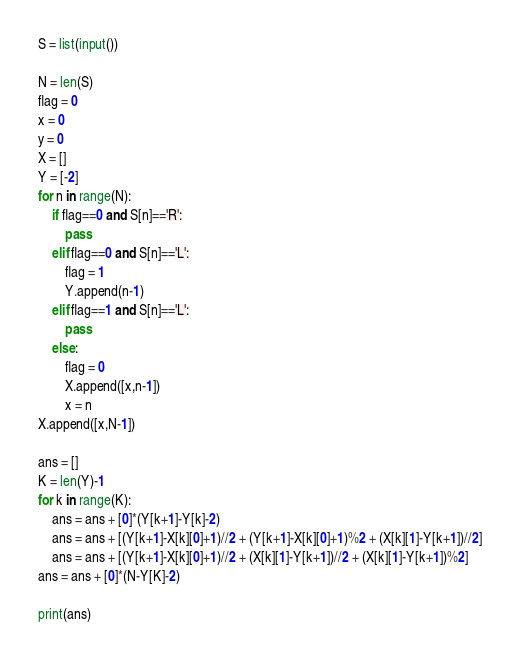<code> <loc_0><loc_0><loc_500><loc_500><_Python_>S = list(input())

N = len(S)
flag = 0
x = 0
y = 0
X = []
Y = [-2]
for n in range(N):
    if flag==0 and S[n]=='R':
        pass
    elif flag==0 and S[n]=='L':
        flag = 1
        Y.append(n-1)
    elif flag==1 and S[n]=='L':
        pass
    else:
        flag = 0
        X.append([x,n-1])
        x = n
X.append([x,N-1])

ans = []
K = len(Y)-1
for k in range(K):
    ans = ans + [0]*(Y[k+1]-Y[k]-2)
    ans = ans + [(Y[k+1]-X[k][0]+1)//2 + (Y[k+1]-X[k][0]+1)%2 + (X[k][1]-Y[k+1])//2]
    ans = ans + [(Y[k+1]-X[k][0]+1)//2 + (X[k][1]-Y[k+1])//2 + (X[k][1]-Y[k+1])%2]
ans = ans + [0]*(N-Y[K]-2)

print(ans)</code> 